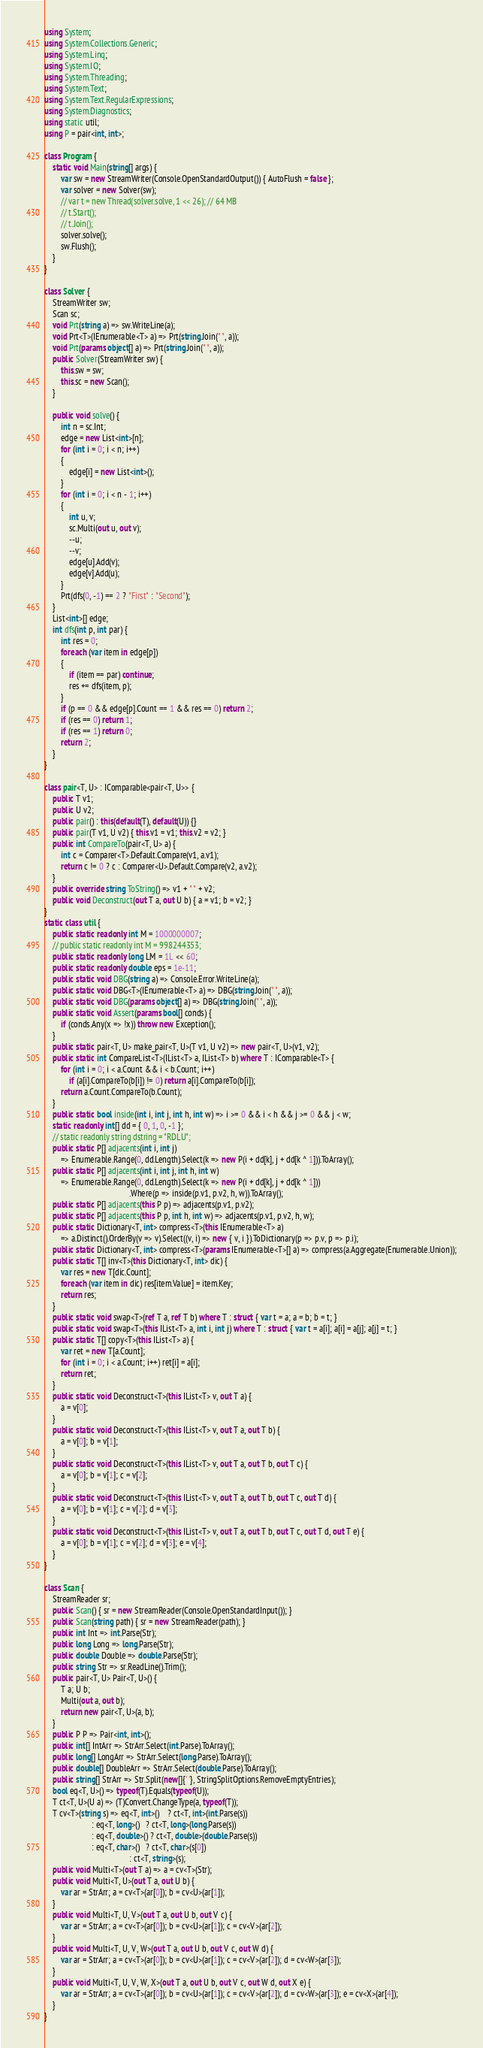Convert code to text. <code><loc_0><loc_0><loc_500><loc_500><_C#_>using System;
using System.Collections.Generic;
using System.Linq;
using System.IO;
using System.Threading;
using System.Text;
using System.Text.RegularExpressions;
using System.Diagnostics;
using static util;
using P = pair<int, int>;

class Program {
    static void Main(string[] args) {
        var sw = new StreamWriter(Console.OpenStandardOutput()) { AutoFlush = false };
        var solver = new Solver(sw);
        // var t = new Thread(solver.solve, 1 << 26); // 64 MB
        // t.Start();
        // t.Join();
        solver.solve();
        sw.Flush();
    }
}

class Solver {
    StreamWriter sw;
    Scan sc;
    void Prt(string a) => sw.WriteLine(a);
    void Prt<T>(IEnumerable<T> a) => Prt(string.Join(" ", a));
    void Prt(params object[] a) => Prt(string.Join(" ", a));
    public Solver(StreamWriter sw) {
        this.sw = sw;
        this.sc = new Scan();
    }

    public void solve() {
        int n = sc.Int;
        edge = new List<int>[n];
        for (int i = 0; i < n; i++)
        {
            edge[i] = new List<int>();
        }
        for (int i = 0; i < n - 1; i++)
        {
            int u, v;
            sc.Multi(out u, out v);
            --u;
            --v;
            edge[u].Add(v);
            edge[v].Add(u);
        }
        Prt(dfs(0, -1) == 2 ? "First" : "Second");
    }
    List<int>[] edge;
    int dfs(int p, int par) {
        int res = 0;
        foreach (var item in edge[p])
        {
            if (item == par) continue;
            res += dfs(item, p);
        }
        if (p == 0 && edge[p].Count == 1 && res == 0) return 2;
        if (res == 0) return 1;
        if (res == 1) return 0;
        return 2;
    }
}

class pair<T, U> : IComparable<pair<T, U>> {
    public T v1;
    public U v2;
    public pair() : this(default(T), default(U)) {}
    public pair(T v1, U v2) { this.v1 = v1; this.v2 = v2; }
    public int CompareTo(pair<T, U> a) {
        int c = Comparer<T>.Default.Compare(v1, a.v1);
        return c != 0 ? c : Comparer<U>.Default.Compare(v2, a.v2);
    }
    public override string ToString() => v1 + " " + v2;
    public void Deconstruct(out T a, out U b) { a = v1; b = v2; }
}
static class util {
    public static readonly int M = 1000000007;
    // public static readonly int M = 998244353;
    public static readonly long LM = 1L << 60;
    public static readonly double eps = 1e-11;
    public static void DBG(string a) => Console.Error.WriteLine(a);
    public static void DBG<T>(IEnumerable<T> a) => DBG(string.Join(" ", a));
    public static void DBG(params object[] a) => DBG(string.Join(" ", a));
    public static void Assert(params bool[] conds) {
        if (conds.Any(x => !x)) throw new Exception();
    }
    public static pair<T, U> make_pair<T, U>(T v1, U v2) => new pair<T, U>(v1, v2);
    public static int CompareList<T>(IList<T> a, IList<T> b) where T : IComparable<T> {
        for (int i = 0; i < a.Count && i < b.Count; i++)
            if (a[i].CompareTo(b[i]) != 0) return a[i].CompareTo(b[i]);
        return a.Count.CompareTo(b.Count);
    }
    public static bool inside(int i, int j, int h, int w) => i >= 0 && i < h && j >= 0 && j < w;
    static readonly int[] dd = { 0, 1, 0, -1 };
    // static readonly string dstring = "RDLU";
    public static P[] adjacents(int i, int j)
        => Enumerable.Range(0, dd.Length).Select(k => new P(i + dd[k], j + dd[k ^ 1])).ToArray();
    public static P[] adjacents(int i, int j, int h, int w)
        => Enumerable.Range(0, dd.Length).Select(k => new P(i + dd[k], j + dd[k ^ 1]))
                                         .Where(p => inside(p.v1, p.v2, h, w)).ToArray();
    public static P[] adjacents(this P p) => adjacents(p.v1, p.v2);
    public static P[] adjacents(this P p, int h, int w) => adjacents(p.v1, p.v2, h, w);
    public static Dictionary<T, int> compress<T>(this IEnumerable<T> a)
        => a.Distinct().OrderBy(v => v).Select((v, i) => new { v, i }).ToDictionary(p => p.v, p => p.i);
    public static Dictionary<T, int> compress<T>(params IEnumerable<T>[] a) => compress(a.Aggregate(Enumerable.Union));
    public static T[] inv<T>(this Dictionary<T, int> dic) {
        var res = new T[dic.Count];
        foreach (var item in dic) res[item.Value] = item.Key;
        return res;
    }
    public static void swap<T>(ref T a, ref T b) where T : struct { var t = a; a = b; b = t; }
    public static void swap<T>(this IList<T> a, int i, int j) where T : struct { var t = a[i]; a[i] = a[j]; a[j] = t; }
    public static T[] copy<T>(this IList<T> a) {
        var ret = new T[a.Count];
        for (int i = 0; i < a.Count; i++) ret[i] = a[i];
        return ret;
    }
    public static void Deconstruct<T>(this IList<T> v, out T a) {
        a = v[0];
    }
    public static void Deconstruct<T>(this IList<T> v, out T a, out T b) {
        a = v[0]; b = v[1];
    }
    public static void Deconstruct<T>(this IList<T> v, out T a, out T b, out T c) {
        a = v[0]; b = v[1]; c = v[2];
    }
    public static void Deconstruct<T>(this IList<T> v, out T a, out T b, out T c, out T d) {
        a = v[0]; b = v[1]; c = v[2]; d = v[3];
    }
    public static void Deconstruct<T>(this IList<T> v, out T a, out T b, out T c, out T d, out T e) {
        a = v[0]; b = v[1]; c = v[2]; d = v[3]; e = v[4];
    }
}

class Scan {
    StreamReader sr;
    public Scan() { sr = new StreamReader(Console.OpenStandardInput()); }
    public Scan(string path) { sr = new StreamReader(path); }
    public int Int => int.Parse(Str);
    public long Long => long.Parse(Str);
    public double Double => double.Parse(Str);
    public string Str => sr.ReadLine().Trim();
    public pair<T, U> Pair<T, U>() {
        T a; U b;
        Multi(out a, out b);
        return new pair<T, U>(a, b);
    }
    public P P => Pair<int, int>();
    public int[] IntArr => StrArr.Select(int.Parse).ToArray();
    public long[] LongArr => StrArr.Select(long.Parse).ToArray();
    public double[] DoubleArr => StrArr.Select(double.Parse).ToArray();
    public string[] StrArr => Str.Split(new[]{' '}, StringSplitOptions.RemoveEmptyEntries);
    bool eq<T, U>() => typeof(T).Equals(typeof(U));
    T ct<T, U>(U a) => (T)Convert.ChangeType(a, typeof(T));
    T cv<T>(string s) => eq<T, int>()    ? ct<T, int>(int.Parse(s))
                       : eq<T, long>()   ? ct<T, long>(long.Parse(s))
                       : eq<T, double>() ? ct<T, double>(double.Parse(s))
                       : eq<T, char>()   ? ct<T, char>(s[0])
                                         : ct<T, string>(s);
    public void Multi<T>(out T a) => a = cv<T>(Str);
    public void Multi<T, U>(out T a, out U b) {
        var ar = StrArr; a = cv<T>(ar[0]); b = cv<U>(ar[1]);
    }
    public void Multi<T, U, V>(out T a, out U b, out V c) {
        var ar = StrArr; a = cv<T>(ar[0]); b = cv<U>(ar[1]); c = cv<V>(ar[2]);
    }
    public void Multi<T, U, V, W>(out T a, out U b, out V c, out W d) {
        var ar = StrArr; a = cv<T>(ar[0]); b = cv<U>(ar[1]); c = cv<V>(ar[2]); d = cv<W>(ar[3]);
    }
    public void Multi<T, U, V, W, X>(out T a, out U b, out V c, out W d, out X e) {
        var ar = StrArr; a = cv<T>(ar[0]); b = cv<U>(ar[1]); c = cv<V>(ar[2]); d = cv<W>(ar[3]); e = cv<X>(ar[4]);
    }
}
</code> 